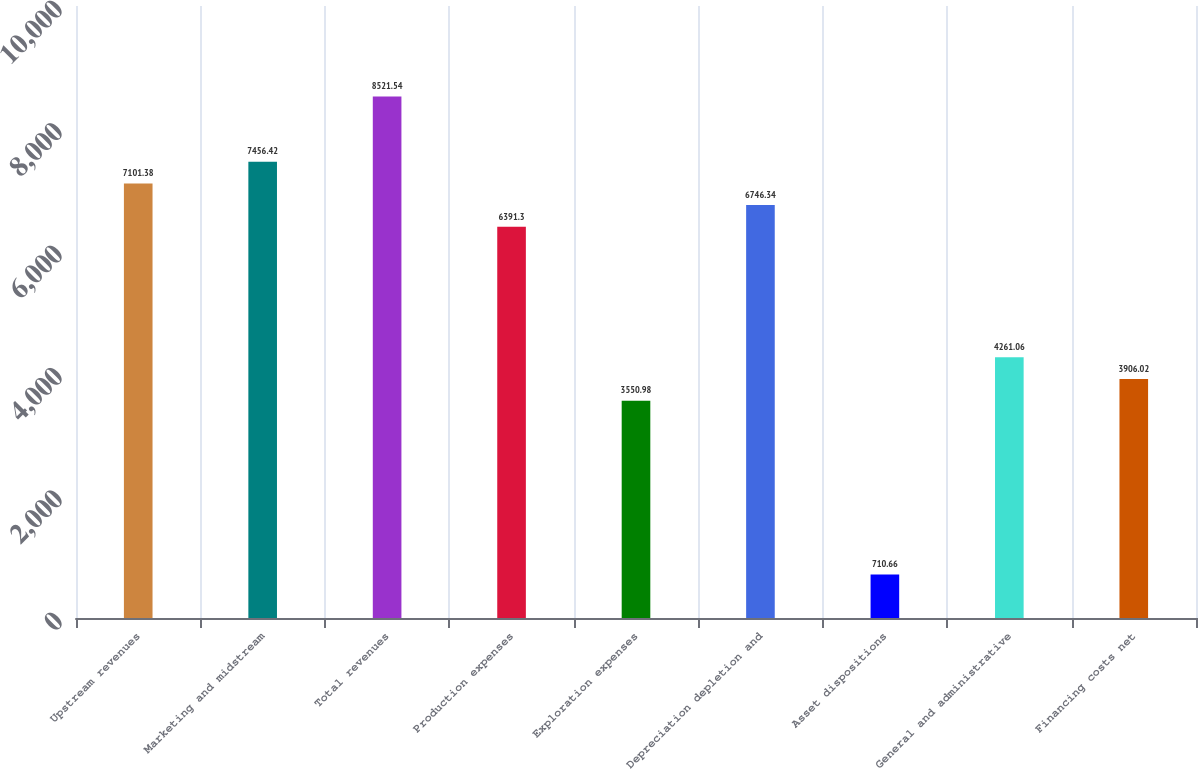Convert chart. <chart><loc_0><loc_0><loc_500><loc_500><bar_chart><fcel>Upstream revenues<fcel>Marketing and midstream<fcel>Total revenues<fcel>Production expenses<fcel>Exploration expenses<fcel>Depreciation depletion and<fcel>Asset dispositions<fcel>General and administrative<fcel>Financing costs net<nl><fcel>7101.38<fcel>7456.42<fcel>8521.54<fcel>6391.3<fcel>3550.98<fcel>6746.34<fcel>710.66<fcel>4261.06<fcel>3906.02<nl></chart> 